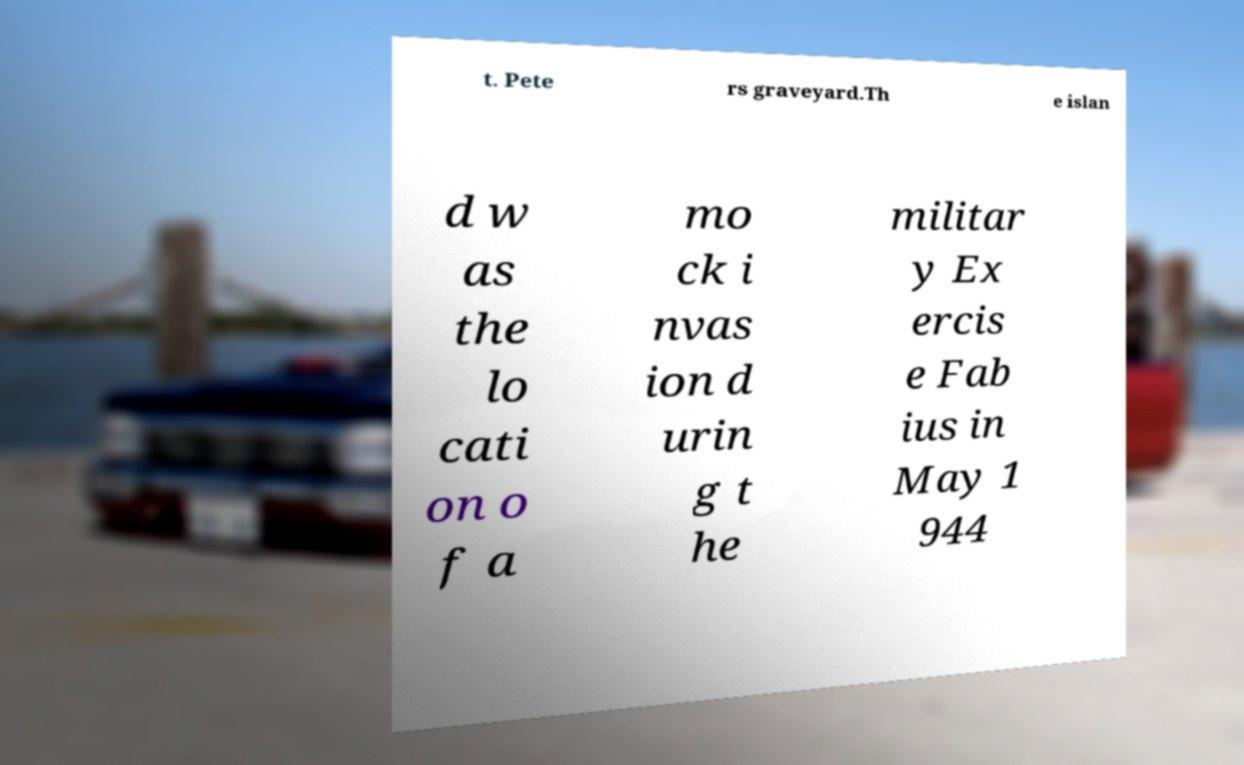For documentation purposes, I need the text within this image transcribed. Could you provide that? t. Pete rs graveyard.Th e islan d w as the lo cati on o f a mo ck i nvas ion d urin g t he militar y Ex ercis e Fab ius in May 1 944 